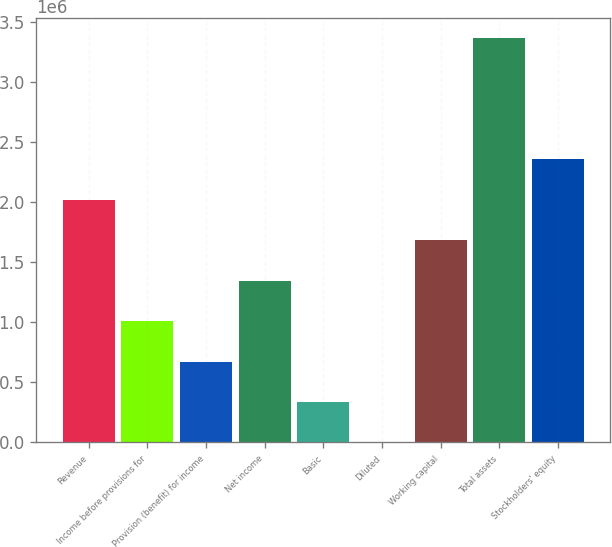Convert chart. <chart><loc_0><loc_0><loc_500><loc_500><bar_chart><fcel>Revenue<fcel>Income before provisions for<fcel>Provision (benefit) for income<fcel>Net income<fcel>Basic<fcel>Diluted<fcel>Working capital<fcel>Total assets<fcel>Stockholders' equity<nl><fcel>2.02131e+06<fcel>1.01065e+06<fcel>673770<fcel>1.34754e+06<fcel>336886<fcel>1.47<fcel>1.68442e+06<fcel>3.36884e+06<fcel>2.35819e+06<nl></chart> 